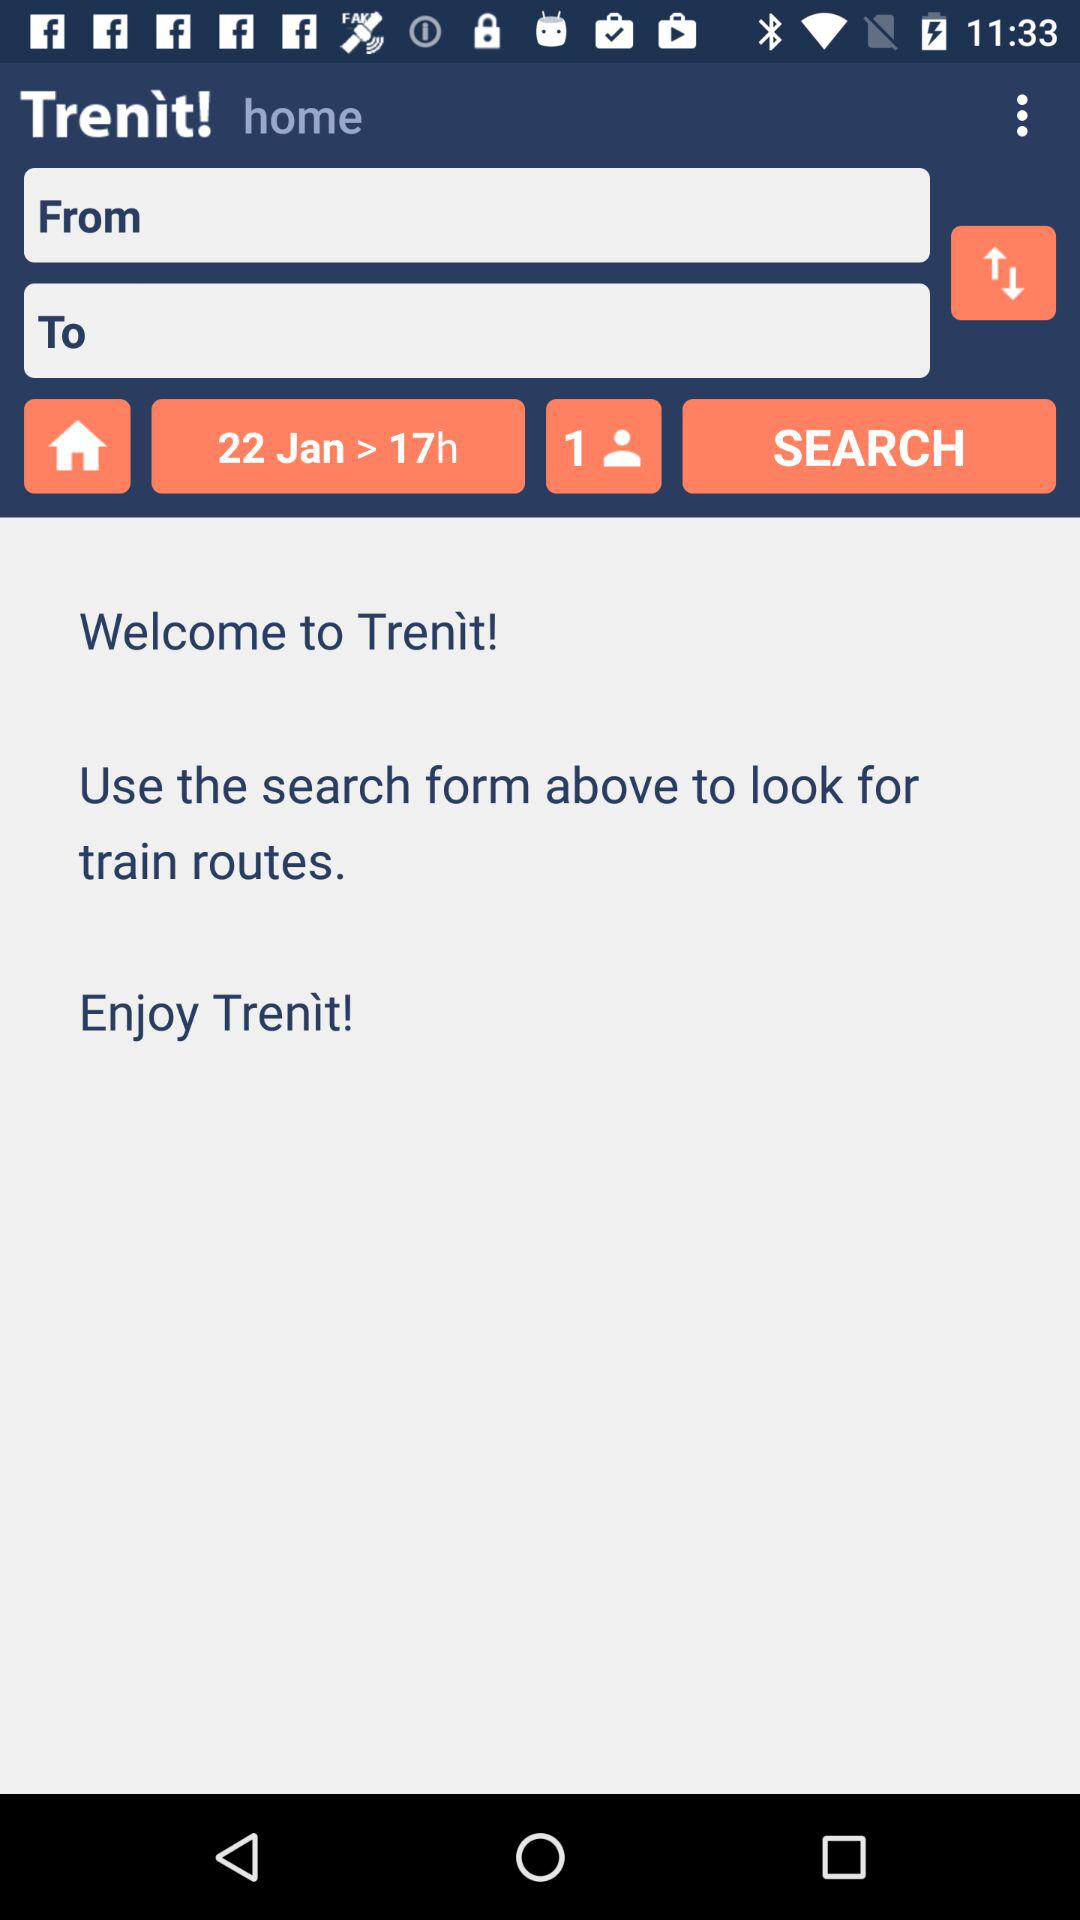What's the date of the journey? The date of the journey is January 22. 